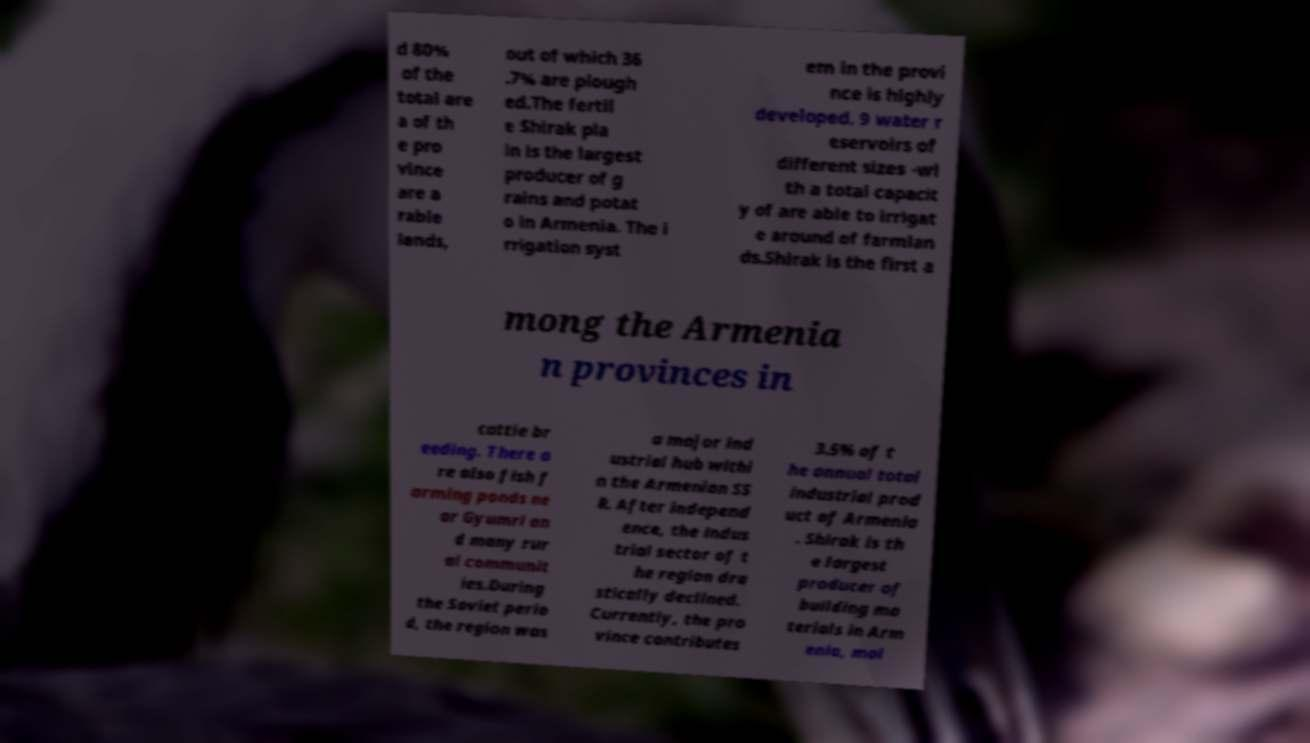Can you accurately transcribe the text from the provided image for me? d 80% of the total are a of th e pro vince are a rable lands, out of which 36 .7% are plough ed.The fertil e Shirak pla in is the largest producer of g rains and potat o in Armenia. The i rrigation syst em in the provi nce is highly developed. 9 water r eservoirs of different sizes -wi th a total capacit y of are able to irrigat e around of farmlan ds.Shirak is the first a mong the Armenia n provinces in cattle br eeding. There a re also fish f arming ponds ne ar Gyumri an d many rur al communit ies.During the Soviet perio d, the region was a major ind ustrial hub withi n the Armenian SS R. After independ ence, the indus trial sector of t he region dra stically declined. Currently, the pro vince contributes 3.5% of t he annual total industrial prod uct of Armenia . Shirak is th e largest producer of building ma terials in Arm enia, mai 